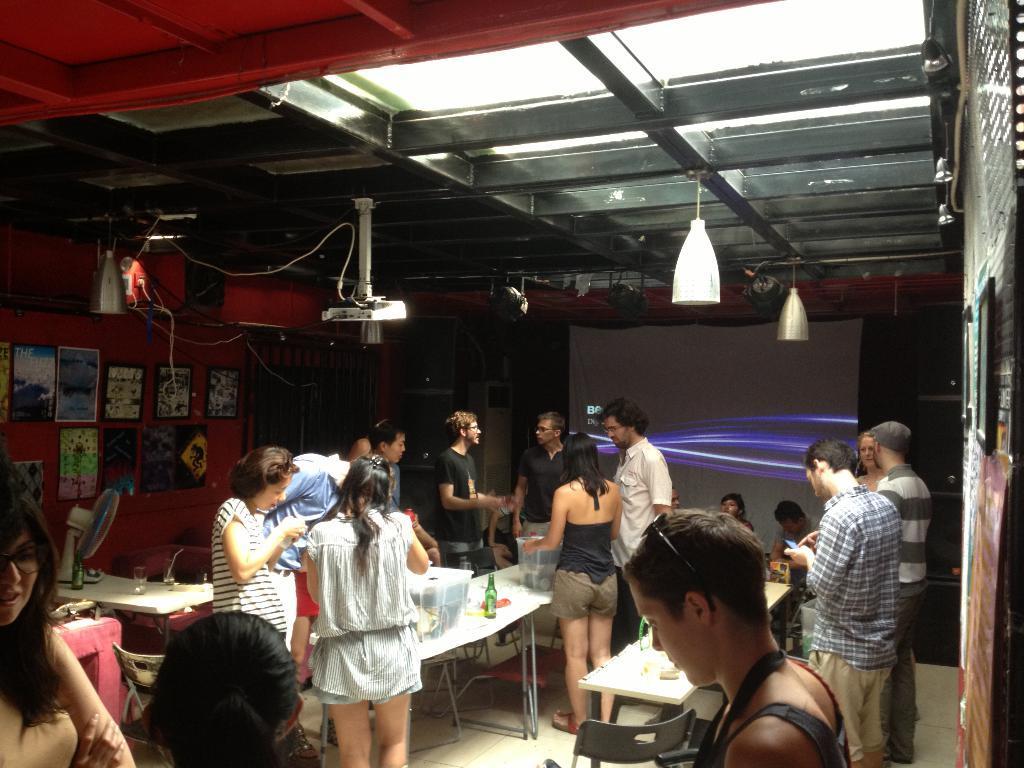Please provide a concise description of this image. In this image, we can see tables, there are some people standing, we can see a wall, there are some photos on the wall. 